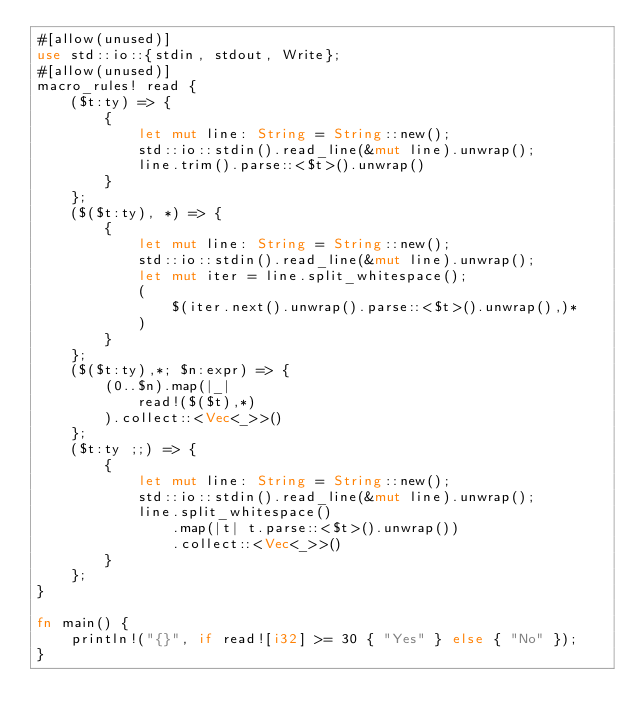<code> <loc_0><loc_0><loc_500><loc_500><_Rust_>#[allow(unused)]
use std::io::{stdin, stdout, Write};    
#[allow(unused)]
macro_rules! read {
    ($t:ty) => {
        {
            let mut line: String = String::new();
            std::io::stdin().read_line(&mut line).unwrap();
            line.trim().parse::<$t>().unwrap()
        }
    };
    ($($t:ty), *) => {
        {
            let mut line: String = String::new();
            std::io::stdin().read_line(&mut line).unwrap();
            let mut iter = line.split_whitespace();
            (
                $(iter.next().unwrap().parse::<$t>().unwrap(),)*
            )
        }
    };
    ($($t:ty),*; $n:expr) => {
        (0..$n).map(|_|
            read!($($t),*)
        ).collect::<Vec<_>>()
    };
    ($t:ty ;;) => {
        {
            let mut line: String = String::new();
            std::io::stdin().read_line(&mut line).unwrap();
            line.split_whitespace()
                .map(|t| t.parse::<$t>().unwrap())
                .collect::<Vec<_>>()
        }
    };
}

fn main() {
    println!("{}", if read![i32] >= 30 { "Yes" } else { "No" });
}</code> 